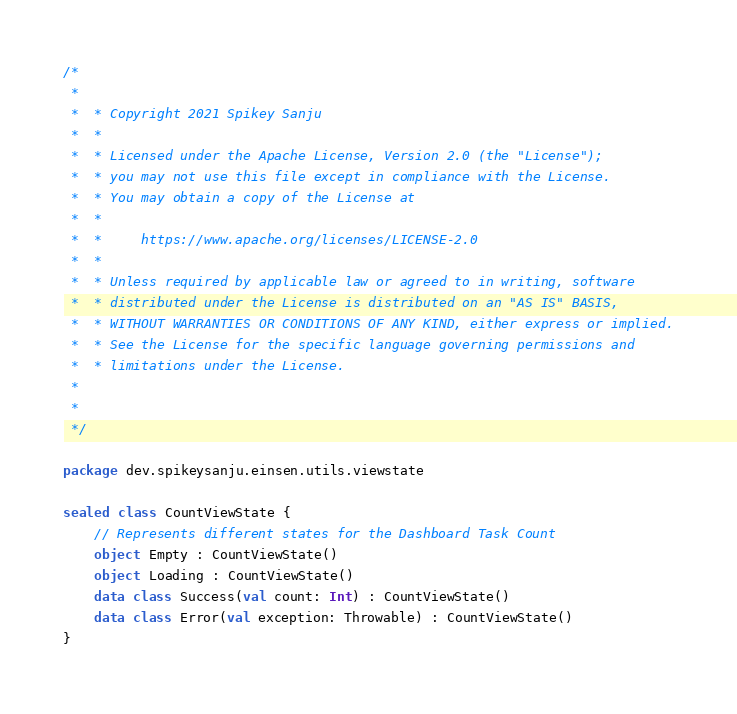Convert code to text. <code><loc_0><loc_0><loc_500><loc_500><_Kotlin_>/*
 *
 *  * Copyright 2021 Spikey Sanju
 *  *
 *  * Licensed under the Apache License, Version 2.0 (the "License");
 *  * you may not use this file except in compliance with the License.
 *  * You may obtain a copy of the License at
 *  *
 *  *     https://www.apache.org/licenses/LICENSE-2.0
 *  *
 *  * Unless required by applicable law or agreed to in writing, software
 *  * distributed under the License is distributed on an "AS IS" BASIS,
 *  * WITHOUT WARRANTIES OR CONDITIONS OF ANY KIND, either express or implied.
 *  * See the License for the specific language governing permissions and
 *  * limitations under the License.
 *
 *
 */

package dev.spikeysanju.einsen.utils.viewstate

sealed class CountViewState {
    // Represents different states for the Dashboard Task Count
    object Empty : CountViewState()
    object Loading : CountViewState()
    data class Success(val count: Int) : CountViewState()
    data class Error(val exception: Throwable) : CountViewState()
}
</code> 